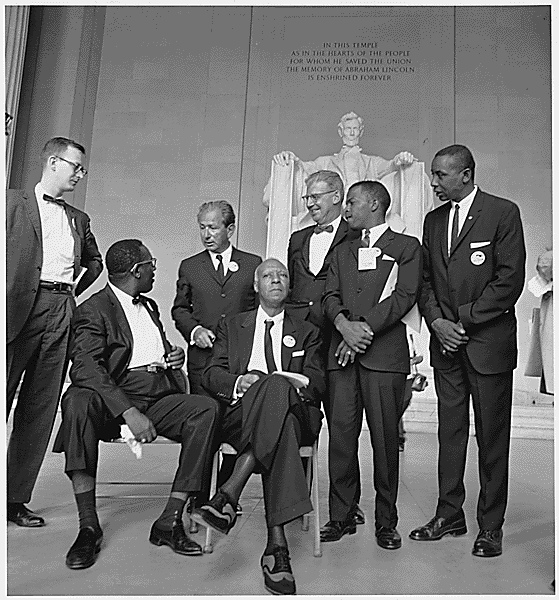Read all the text in this image. FOREVER TEMPLE HEARTS UNCOIN IS UNCOIN ABRAHAM OF MEMORY THE SAVED HE WHOM FOR PEOPLE THE IN AS THIS IN 